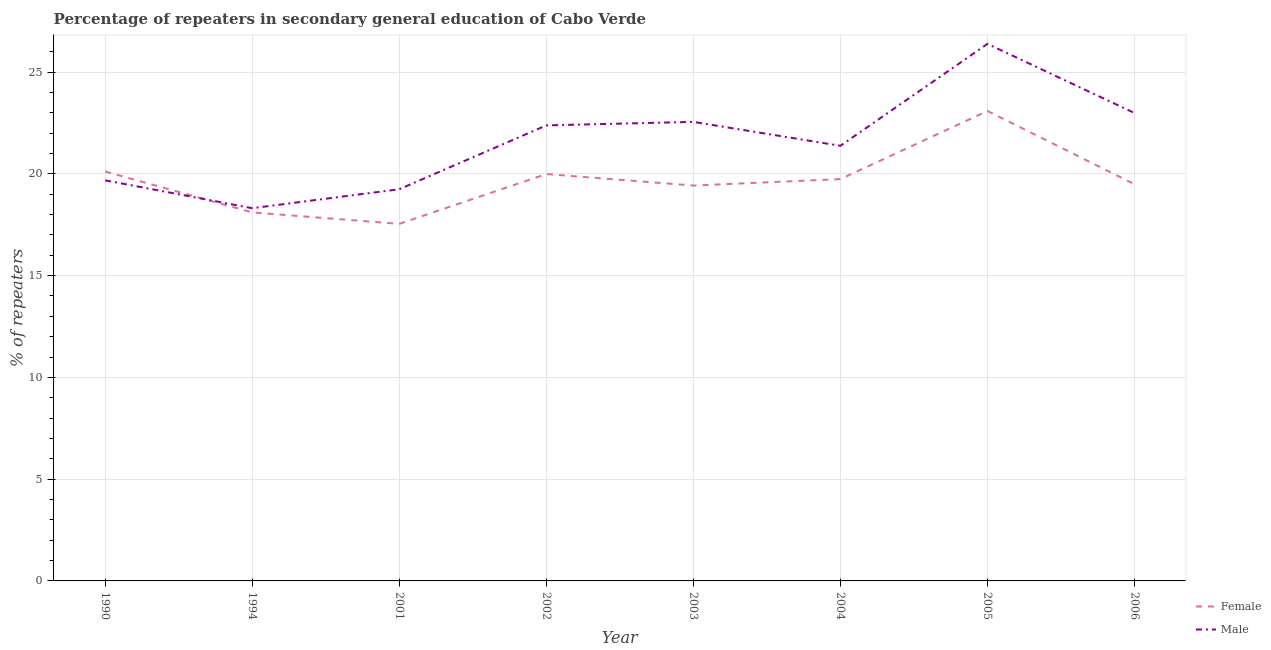Is the number of lines equal to the number of legend labels?
Make the answer very short. Yes. What is the percentage of female repeaters in 2004?
Your answer should be very brief. 19.74. Across all years, what is the maximum percentage of female repeaters?
Ensure brevity in your answer.  23.09. Across all years, what is the minimum percentage of male repeaters?
Keep it short and to the point. 18.31. In which year was the percentage of male repeaters minimum?
Your answer should be compact. 1994. What is the total percentage of female repeaters in the graph?
Make the answer very short. 157.5. What is the difference between the percentage of male repeaters in 1994 and that in 2004?
Your answer should be compact. -3.06. What is the difference between the percentage of female repeaters in 2005 and the percentage of male repeaters in 2003?
Ensure brevity in your answer.  0.54. What is the average percentage of male repeaters per year?
Your response must be concise. 21.62. In the year 2004, what is the difference between the percentage of male repeaters and percentage of female repeaters?
Give a very brief answer. 1.64. What is the ratio of the percentage of male repeaters in 2001 to that in 2005?
Your answer should be compact. 0.73. Is the percentage of male repeaters in 1994 less than that in 2005?
Give a very brief answer. Yes. Is the difference between the percentage of male repeaters in 1990 and 1994 greater than the difference between the percentage of female repeaters in 1990 and 1994?
Make the answer very short. No. What is the difference between the highest and the second highest percentage of female repeaters?
Your answer should be very brief. 2.98. What is the difference between the highest and the lowest percentage of male repeaters?
Your answer should be very brief. 8.07. In how many years, is the percentage of female repeaters greater than the average percentage of female repeaters taken over all years?
Give a very brief answer. 4. Is the sum of the percentage of female repeaters in 1994 and 2003 greater than the maximum percentage of male repeaters across all years?
Your answer should be very brief. Yes. Is the percentage of female repeaters strictly less than the percentage of male repeaters over the years?
Make the answer very short. No. How many lines are there?
Your answer should be compact. 2. What is the difference between two consecutive major ticks on the Y-axis?
Provide a succinct answer. 5. Does the graph contain any zero values?
Ensure brevity in your answer.  No. Where does the legend appear in the graph?
Your answer should be very brief. Bottom right. How many legend labels are there?
Offer a very short reply. 2. How are the legend labels stacked?
Ensure brevity in your answer.  Vertical. What is the title of the graph?
Offer a terse response. Percentage of repeaters in secondary general education of Cabo Verde. What is the label or title of the Y-axis?
Provide a succinct answer. % of repeaters. What is the % of repeaters of Female in 1990?
Provide a succinct answer. 20.11. What is the % of repeaters in Male in 1990?
Your answer should be compact. 19.68. What is the % of repeaters in Female in 1994?
Ensure brevity in your answer.  18.11. What is the % of repeaters in Male in 1994?
Make the answer very short. 18.31. What is the % of repeaters of Female in 2001?
Provide a succinct answer. 17.54. What is the % of repeaters of Male in 2001?
Your response must be concise. 19.24. What is the % of repeaters of Female in 2002?
Your answer should be very brief. 19.99. What is the % of repeaters of Male in 2002?
Offer a terse response. 22.38. What is the % of repeaters of Female in 2003?
Your answer should be compact. 19.42. What is the % of repeaters of Male in 2003?
Offer a very short reply. 22.55. What is the % of repeaters in Female in 2004?
Provide a short and direct response. 19.74. What is the % of repeaters of Male in 2004?
Your response must be concise. 21.38. What is the % of repeaters of Female in 2005?
Your response must be concise. 23.09. What is the % of repeaters in Male in 2005?
Make the answer very short. 26.39. What is the % of repeaters in Female in 2006?
Make the answer very short. 19.49. What is the % of repeaters in Male in 2006?
Provide a short and direct response. 22.99. Across all years, what is the maximum % of repeaters of Female?
Your response must be concise. 23.09. Across all years, what is the maximum % of repeaters of Male?
Give a very brief answer. 26.39. Across all years, what is the minimum % of repeaters of Female?
Offer a terse response. 17.54. Across all years, what is the minimum % of repeaters in Male?
Offer a terse response. 18.31. What is the total % of repeaters in Female in the graph?
Your answer should be very brief. 157.5. What is the total % of repeaters of Male in the graph?
Provide a succinct answer. 172.92. What is the difference between the % of repeaters of Female in 1990 and that in 1994?
Ensure brevity in your answer.  2.01. What is the difference between the % of repeaters of Male in 1990 and that in 1994?
Give a very brief answer. 1.37. What is the difference between the % of repeaters in Female in 1990 and that in 2001?
Give a very brief answer. 2.57. What is the difference between the % of repeaters of Male in 1990 and that in 2001?
Keep it short and to the point. 0.44. What is the difference between the % of repeaters in Female in 1990 and that in 2002?
Offer a terse response. 0.12. What is the difference between the % of repeaters of Female in 1990 and that in 2003?
Your answer should be very brief. 0.69. What is the difference between the % of repeaters in Male in 1990 and that in 2003?
Offer a terse response. -2.87. What is the difference between the % of repeaters of Female in 1990 and that in 2004?
Your response must be concise. 0.37. What is the difference between the % of repeaters in Male in 1990 and that in 2004?
Ensure brevity in your answer.  -1.7. What is the difference between the % of repeaters of Female in 1990 and that in 2005?
Keep it short and to the point. -2.98. What is the difference between the % of repeaters in Male in 1990 and that in 2005?
Ensure brevity in your answer.  -6.7. What is the difference between the % of repeaters of Female in 1990 and that in 2006?
Offer a terse response. 0.62. What is the difference between the % of repeaters of Male in 1990 and that in 2006?
Your answer should be very brief. -3.31. What is the difference between the % of repeaters in Female in 1994 and that in 2001?
Your answer should be very brief. 0.56. What is the difference between the % of repeaters in Male in 1994 and that in 2001?
Provide a succinct answer. -0.93. What is the difference between the % of repeaters in Female in 1994 and that in 2002?
Ensure brevity in your answer.  -1.88. What is the difference between the % of repeaters in Male in 1994 and that in 2002?
Offer a very short reply. -4.07. What is the difference between the % of repeaters in Female in 1994 and that in 2003?
Ensure brevity in your answer.  -1.32. What is the difference between the % of repeaters in Male in 1994 and that in 2003?
Offer a very short reply. -4.24. What is the difference between the % of repeaters of Female in 1994 and that in 2004?
Offer a terse response. -1.64. What is the difference between the % of repeaters of Male in 1994 and that in 2004?
Make the answer very short. -3.06. What is the difference between the % of repeaters of Female in 1994 and that in 2005?
Your answer should be compact. -4.98. What is the difference between the % of repeaters of Male in 1994 and that in 2005?
Offer a terse response. -8.07. What is the difference between the % of repeaters of Female in 1994 and that in 2006?
Keep it short and to the point. -1.38. What is the difference between the % of repeaters in Male in 1994 and that in 2006?
Provide a short and direct response. -4.68. What is the difference between the % of repeaters in Female in 2001 and that in 2002?
Give a very brief answer. -2.45. What is the difference between the % of repeaters in Male in 2001 and that in 2002?
Keep it short and to the point. -3.14. What is the difference between the % of repeaters of Female in 2001 and that in 2003?
Your response must be concise. -1.88. What is the difference between the % of repeaters of Male in 2001 and that in 2003?
Your response must be concise. -3.31. What is the difference between the % of repeaters of Female in 2001 and that in 2004?
Provide a succinct answer. -2.2. What is the difference between the % of repeaters in Male in 2001 and that in 2004?
Your answer should be compact. -2.13. What is the difference between the % of repeaters of Female in 2001 and that in 2005?
Your answer should be compact. -5.55. What is the difference between the % of repeaters in Male in 2001 and that in 2005?
Your answer should be very brief. -7.14. What is the difference between the % of repeaters in Female in 2001 and that in 2006?
Offer a very short reply. -1.95. What is the difference between the % of repeaters in Male in 2001 and that in 2006?
Your answer should be very brief. -3.74. What is the difference between the % of repeaters in Female in 2002 and that in 2003?
Your answer should be compact. 0.57. What is the difference between the % of repeaters of Male in 2002 and that in 2003?
Provide a short and direct response. -0.17. What is the difference between the % of repeaters of Female in 2002 and that in 2004?
Your answer should be compact. 0.25. What is the difference between the % of repeaters of Male in 2002 and that in 2004?
Keep it short and to the point. 1. What is the difference between the % of repeaters in Female in 2002 and that in 2005?
Provide a short and direct response. -3.1. What is the difference between the % of repeaters in Male in 2002 and that in 2005?
Provide a succinct answer. -4. What is the difference between the % of repeaters in Female in 2002 and that in 2006?
Provide a short and direct response. 0.5. What is the difference between the % of repeaters of Male in 2002 and that in 2006?
Offer a terse response. -0.61. What is the difference between the % of repeaters of Female in 2003 and that in 2004?
Make the answer very short. -0.32. What is the difference between the % of repeaters in Male in 2003 and that in 2004?
Provide a short and direct response. 1.18. What is the difference between the % of repeaters of Female in 2003 and that in 2005?
Your response must be concise. -3.67. What is the difference between the % of repeaters in Male in 2003 and that in 2005?
Provide a succinct answer. -3.83. What is the difference between the % of repeaters of Female in 2003 and that in 2006?
Make the answer very short. -0.07. What is the difference between the % of repeaters in Male in 2003 and that in 2006?
Ensure brevity in your answer.  -0.44. What is the difference between the % of repeaters of Female in 2004 and that in 2005?
Offer a terse response. -3.35. What is the difference between the % of repeaters of Male in 2004 and that in 2005?
Make the answer very short. -5.01. What is the difference between the % of repeaters in Female in 2004 and that in 2006?
Keep it short and to the point. 0.25. What is the difference between the % of repeaters in Male in 2004 and that in 2006?
Give a very brief answer. -1.61. What is the difference between the % of repeaters in Female in 2005 and that in 2006?
Keep it short and to the point. 3.6. What is the difference between the % of repeaters of Male in 2005 and that in 2006?
Your answer should be very brief. 3.4. What is the difference between the % of repeaters in Female in 1990 and the % of repeaters in Male in 1994?
Provide a succinct answer. 1.8. What is the difference between the % of repeaters of Female in 1990 and the % of repeaters of Male in 2001?
Ensure brevity in your answer.  0.87. What is the difference between the % of repeaters in Female in 1990 and the % of repeaters in Male in 2002?
Offer a terse response. -2.27. What is the difference between the % of repeaters of Female in 1990 and the % of repeaters of Male in 2003?
Your answer should be very brief. -2.44. What is the difference between the % of repeaters in Female in 1990 and the % of repeaters in Male in 2004?
Your answer should be compact. -1.26. What is the difference between the % of repeaters in Female in 1990 and the % of repeaters in Male in 2005?
Offer a terse response. -6.27. What is the difference between the % of repeaters of Female in 1990 and the % of repeaters of Male in 2006?
Offer a terse response. -2.87. What is the difference between the % of repeaters in Female in 1994 and the % of repeaters in Male in 2001?
Provide a short and direct response. -1.14. What is the difference between the % of repeaters of Female in 1994 and the % of repeaters of Male in 2002?
Ensure brevity in your answer.  -4.28. What is the difference between the % of repeaters of Female in 1994 and the % of repeaters of Male in 2003?
Your answer should be compact. -4.45. What is the difference between the % of repeaters in Female in 1994 and the % of repeaters in Male in 2004?
Provide a short and direct response. -3.27. What is the difference between the % of repeaters of Female in 1994 and the % of repeaters of Male in 2005?
Keep it short and to the point. -8.28. What is the difference between the % of repeaters of Female in 1994 and the % of repeaters of Male in 2006?
Provide a succinct answer. -4.88. What is the difference between the % of repeaters of Female in 2001 and the % of repeaters of Male in 2002?
Your answer should be compact. -4.84. What is the difference between the % of repeaters of Female in 2001 and the % of repeaters of Male in 2003?
Your answer should be compact. -5.01. What is the difference between the % of repeaters in Female in 2001 and the % of repeaters in Male in 2004?
Your response must be concise. -3.83. What is the difference between the % of repeaters of Female in 2001 and the % of repeaters of Male in 2005?
Offer a terse response. -8.84. What is the difference between the % of repeaters in Female in 2001 and the % of repeaters in Male in 2006?
Give a very brief answer. -5.45. What is the difference between the % of repeaters in Female in 2002 and the % of repeaters in Male in 2003?
Give a very brief answer. -2.56. What is the difference between the % of repeaters of Female in 2002 and the % of repeaters of Male in 2004?
Your response must be concise. -1.39. What is the difference between the % of repeaters in Female in 2002 and the % of repeaters in Male in 2005?
Offer a very short reply. -6.39. What is the difference between the % of repeaters in Female in 2002 and the % of repeaters in Male in 2006?
Provide a short and direct response. -3. What is the difference between the % of repeaters in Female in 2003 and the % of repeaters in Male in 2004?
Your answer should be compact. -1.95. What is the difference between the % of repeaters of Female in 2003 and the % of repeaters of Male in 2005?
Make the answer very short. -6.96. What is the difference between the % of repeaters of Female in 2003 and the % of repeaters of Male in 2006?
Your answer should be very brief. -3.56. What is the difference between the % of repeaters in Female in 2004 and the % of repeaters in Male in 2005?
Offer a terse response. -6.64. What is the difference between the % of repeaters in Female in 2004 and the % of repeaters in Male in 2006?
Give a very brief answer. -3.25. What is the difference between the % of repeaters in Female in 2005 and the % of repeaters in Male in 2006?
Your response must be concise. 0.1. What is the average % of repeaters in Female per year?
Provide a succinct answer. 19.69. What is the average % of repeaters of Male per year?
Give a very brief answer. 21.62. In the year 1990, what is the difference between the % of repeaters of Female and % of repeaters of Male?
Give a very brief answer. 0.43. In the year 1994, what is the difference between the % of repeaters in Female and % of repeaters in Male?
Your answer should be very brief. -0.21. In the year 2001, what is the difference between the % of repeaters in Female and % of repeaters in Male?
Give a very brief answer. -1.7. In the year 2002, what is the difference between the % of repeaters of Female and % of repeaters of Male?
Give a very brief answer. -2.39. In the year 2003, what is the difference between the % of repeaters in Female and % of repeaters in Male?
Provide a short and direct response. -3.13. In the year 2004, what is the difference between the % of repeaters of Female and % of repeaters of Male?
Give a very brief answer. -1.64. In the year 2005, what is the difference between the % of repeaters of Female and % of repeaters of Male?
Give a very brief answer. -3.3. In the year 2006, what is the difference between the % of repeaters of Female and % of repeaters of Male?
Make the answer very short. -3.5. What is the ratio of the % of repeaters of Female in 1990 to that in 1994?
Provide a succinct answer. 1.11. What is the ratio of the % of repeaters of Male in 1990 to that in 1994?
Offer a terse response. 1.07. What is the ratio of the % of repeaters of Female in 1990 to that in 2001?
Offer a very short reply. 1.15. What is the ratio of the % of repeaters in Male in 1990 to that in 2001?
Offer a terse response. 1.02. What is the ratio of the % of repeaters in Female in 1990 to that in 2002?
Your response must be concise. 1.01. What is the ratio of the % of repeaters in Male in 1990 to that in 2002?
Offer a very short reply. 0.88. What is the ratio of the % of repeaters in Female in 1990 to that in 2003?
Make the answer very short. 1.04. What is the ratio of the % of repeaters in Male in 1990 to that in 2003?
Your response must be concise. 0.87. What is the ratio of the % of repeaters of Female in 1990 to that in 2004?
Ensure brevity in your answer.  1.02. What is the ratio of the % of repeaters in Male in 1990 to that in 2004?
Your answer should be compact. 0.92. What is the ratio of the % of repeaters of Female in 1990 to that in 2005?
Offer a very short reply. 0.87. What is the ratio of the % of repeaters in Male in 1990 to that in 2005?
Your answer should be very brief. 0.75. What is the ratio of the % of repeaters of Female in 1990 to that in 2006?
Provide a short and direct response. 1.03. What is the ratio of the % of repeaters in Male in 1990 to that in 2006?
Provide a succinct answer. 0.86. What is the ratio of the % of repeaters in Female in 1994 to that in 2001?
Make the answer very short. 1.03. What is the ratio of the % of repeaters of Male in 1994 to that in 2001?
Your answer should be very brief. 0.95. What is the ratio of the % of repeaters in Female in 1994 to that in 2002?
Keep it short and to the point. 0.91. What is the ratio of the % of repeaters of Male in 1994 to that in 2002?
Your response must be concise. 0.82. What is the ratio of the % of repeaters in Female in 1994 to that in 2003?
Offer a very short reply. 0.93. What is the ratio of the % of repeaters in Male in 1994 to that in 2003?
Offer a very short reply. 0.81. What is the ratio of the % of repeaters of Female in 1994 to that in 2004?
Provide a short and direct response. 0.92. What is the ratio of the % of repeaters in Male in 1994 to that in 2004?
Keep it short and to the point. 0.86. What is the ratio of the % of repeaters in Female in 1994 to that in 2005?
Make the answer very short. 0.78. What is the ratio of the % of repeaters of Male in 1994 to that in 2005?
Provide a short and direct response. 0.69. What is the ratio of the % of repeaters of Female in 1994 to that in 2006?
Your answer should be very brief. 0.93. What is the ratio of the % of repeaters of Male in 1994 to that in 2006?
Make the answer very short. 0.8. What is the ratio of the % of repeaters of Female in 2001 to that in 2002?
Give a very brief answer. 0.88. What is the ratio of the % of repeaters in Male in 2001 to that in 2002?
Offer a very short reply. 0.86. What is the ratio of the % of repeaters in Female in 2001 to that in 2003?
Offer a very short reply. 0.9. What is the ratio of the % of repeaters of Male in 2001 to that in 2003?
Provide a short and direct response. 0.85. What is the ratio of the % of repeaters in Female in 2001 to that in 2004?
Provide a succinct answer. 0.89. What is the ratio of the % of repeaters of Male in 2001 to that in 2004?
Your response must be concise. 0.9. What is the ratio of the % of repeaters of Female in 2001 to that in 2005?
Offer a very short reply. 0.76. What is the ratio of the % of repeaters in Male in 2001 to that in 2005?
Your answer should be compact. 0.73. What is the ratio of the % of repeaters in Female in 2001 to that in 2006?
Your answer should be very brief. 0.9. What is the ratio of the % of repeaters in Male in 2001 to that in 2006?
Your answer should be compact. 0.84. What is the ratio of the % of repeaters of Female in 2002 to that in 2003?
Keep it short and to the point. 1.03. What is the ratio of the % of repeaters in Female in 2002 to that in 2004?
Provide a short and direct response. 1.01. What is the ratio of the % of repeaters of Male in 2002 to that in 2004?
Your answer should be compact. 1.05. What is the ratio of the % of repeaters in Female in 2002 to that in 2005?
Keep it short and to the point. 0.87. What is the ratio of the % of repeaters of Male in 2002 to that in 2005?
Give a very brief answer. 0.85. What is the ratio of the % of repeaters of Female in 2002 to that in 2006?
Keep it short and to the point. 1.03. What is the ratio of the % of repeaters in Male in 2002 to that in 2006?
Make the answer very short. 0.97. What is the ratio of the % of repeaters in Male in 2003 to that in 2004?
Keep it short and to the point. 1.05. What is the ratio of the % of repeaters of Female in 2003 to that in 2005?
Offer a terse response. 0.84. What is the ratio of the % of repeaters in Male in 2003 to that in 2005?
Keep it short and to the point. 0.85. What is the ratio of the % of repeaters in Male in 2003 to that in 2006?
Offer a terse response. 0.98. What is the ratio of the % of repeaters of Female in 2004 to that in 2005?
Your answer should be compact. 0.85. What is the ratio of the % of repeaters in Male in 2004 to that in 2005?
Your answer should be very brief. 0.81. What is the ratio of the % of repeaters in Female in 2004 to that in 2006?
Provide a succinct answer. 1.01. What is the ratio of the % of repeaters of Male in 2004 to that in 2006?
Make the answer very short. 0.93. What is the ratio of the % of repeaters in Female in 2005 to that in 2006?
Your response must be concise. 1.18. What is the ratio of the % of repeaters in Male in 2005 to that in 2006?
Offer a very short reply. 1.15. What is the difference between the highest and the second highest % of repeaters of Female?
Provide a succinct answer. 2.98. What is the difference between the highest and the second highest % of repeaters in Male?
Provide a succinct answer. 3.4. What is the difference between the highest and the lowest % of repeaters of Female?
Ensure brevity in your answer.  5.55. What is the difference between the highest and the lowest % of repeaters in Male?
Provide a short and direct response. 8.07. 